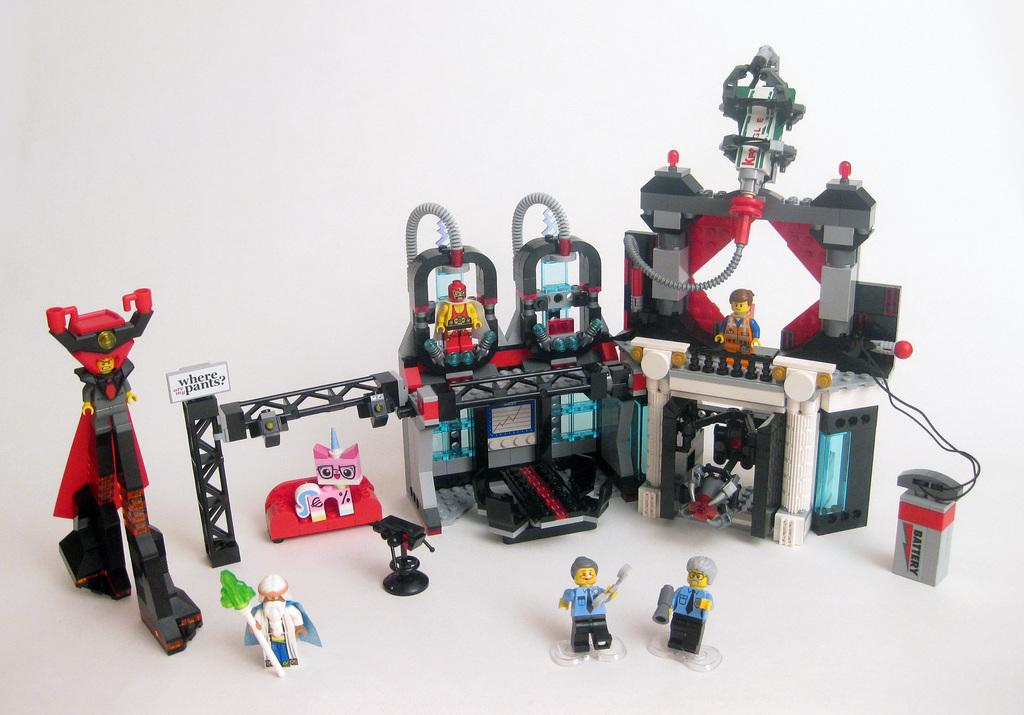What type of toys can be seen in the image? There is a line of plastic construction toys in the image. What power source is present in the image? There is a battery in the image. What color is the background of the image? The background of the image is white. How many lizards are playing on the playground in the image? There are no lizards or playground present in the image. 